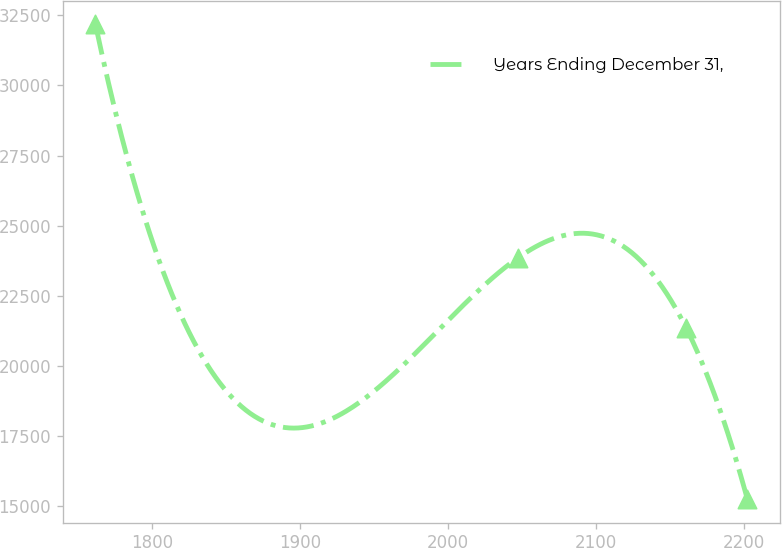<chart> <loc_0><loc_0><loc_500><loc_500><line_chart><ecel><fcel>Years Ending December 31,<nl><fcel>1761.54<fcel>32179.8<nl><fcel>2047.33<fcel>23859.8<nl><fcel>2160.73<fcel>21363.5<nl><fcel>2202.16<fcel>15255.1<nl></chart> 